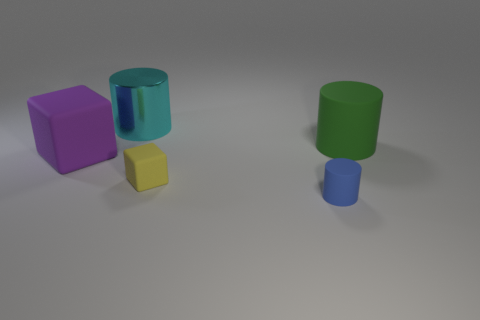The green matte thing that is the same shape as the big cyan shiny object is what size?
Provide a short and direct response. Large. Are there an equal number of big shiny things in front of the small blue matte object and big matte objects on the left side of the shiny object?
Provide a short and direct response. No. How many large gray rubber cubes are there?
Make the answer very short. 0. Are there more large shiny objects that are behind the blue cylinder than small brown rubber balls?
Ensure brevity in your answer.  Yes. There is a large cylinder to the left of the yellow matte thing; what is its material?
Your answer should be compact. Metal. There is another object that is the same shape as the purple matte object; what color is it?
Provide a succinct answer. Yellow. There is a matte cylinder that is behind the blue object; does it have the same size as the matte cylinder that is left of the large green object?
Offer a terse response. No. Is the size of the green cylinder the same as the object that is behind the green thing?
Your answer should be very brief. Yes. What size is the yellow rubber block?
Your answer should be very brief. Small. What color is the big block that is made of the same material as the green thing?
Provide a succinct answer. Purple. 